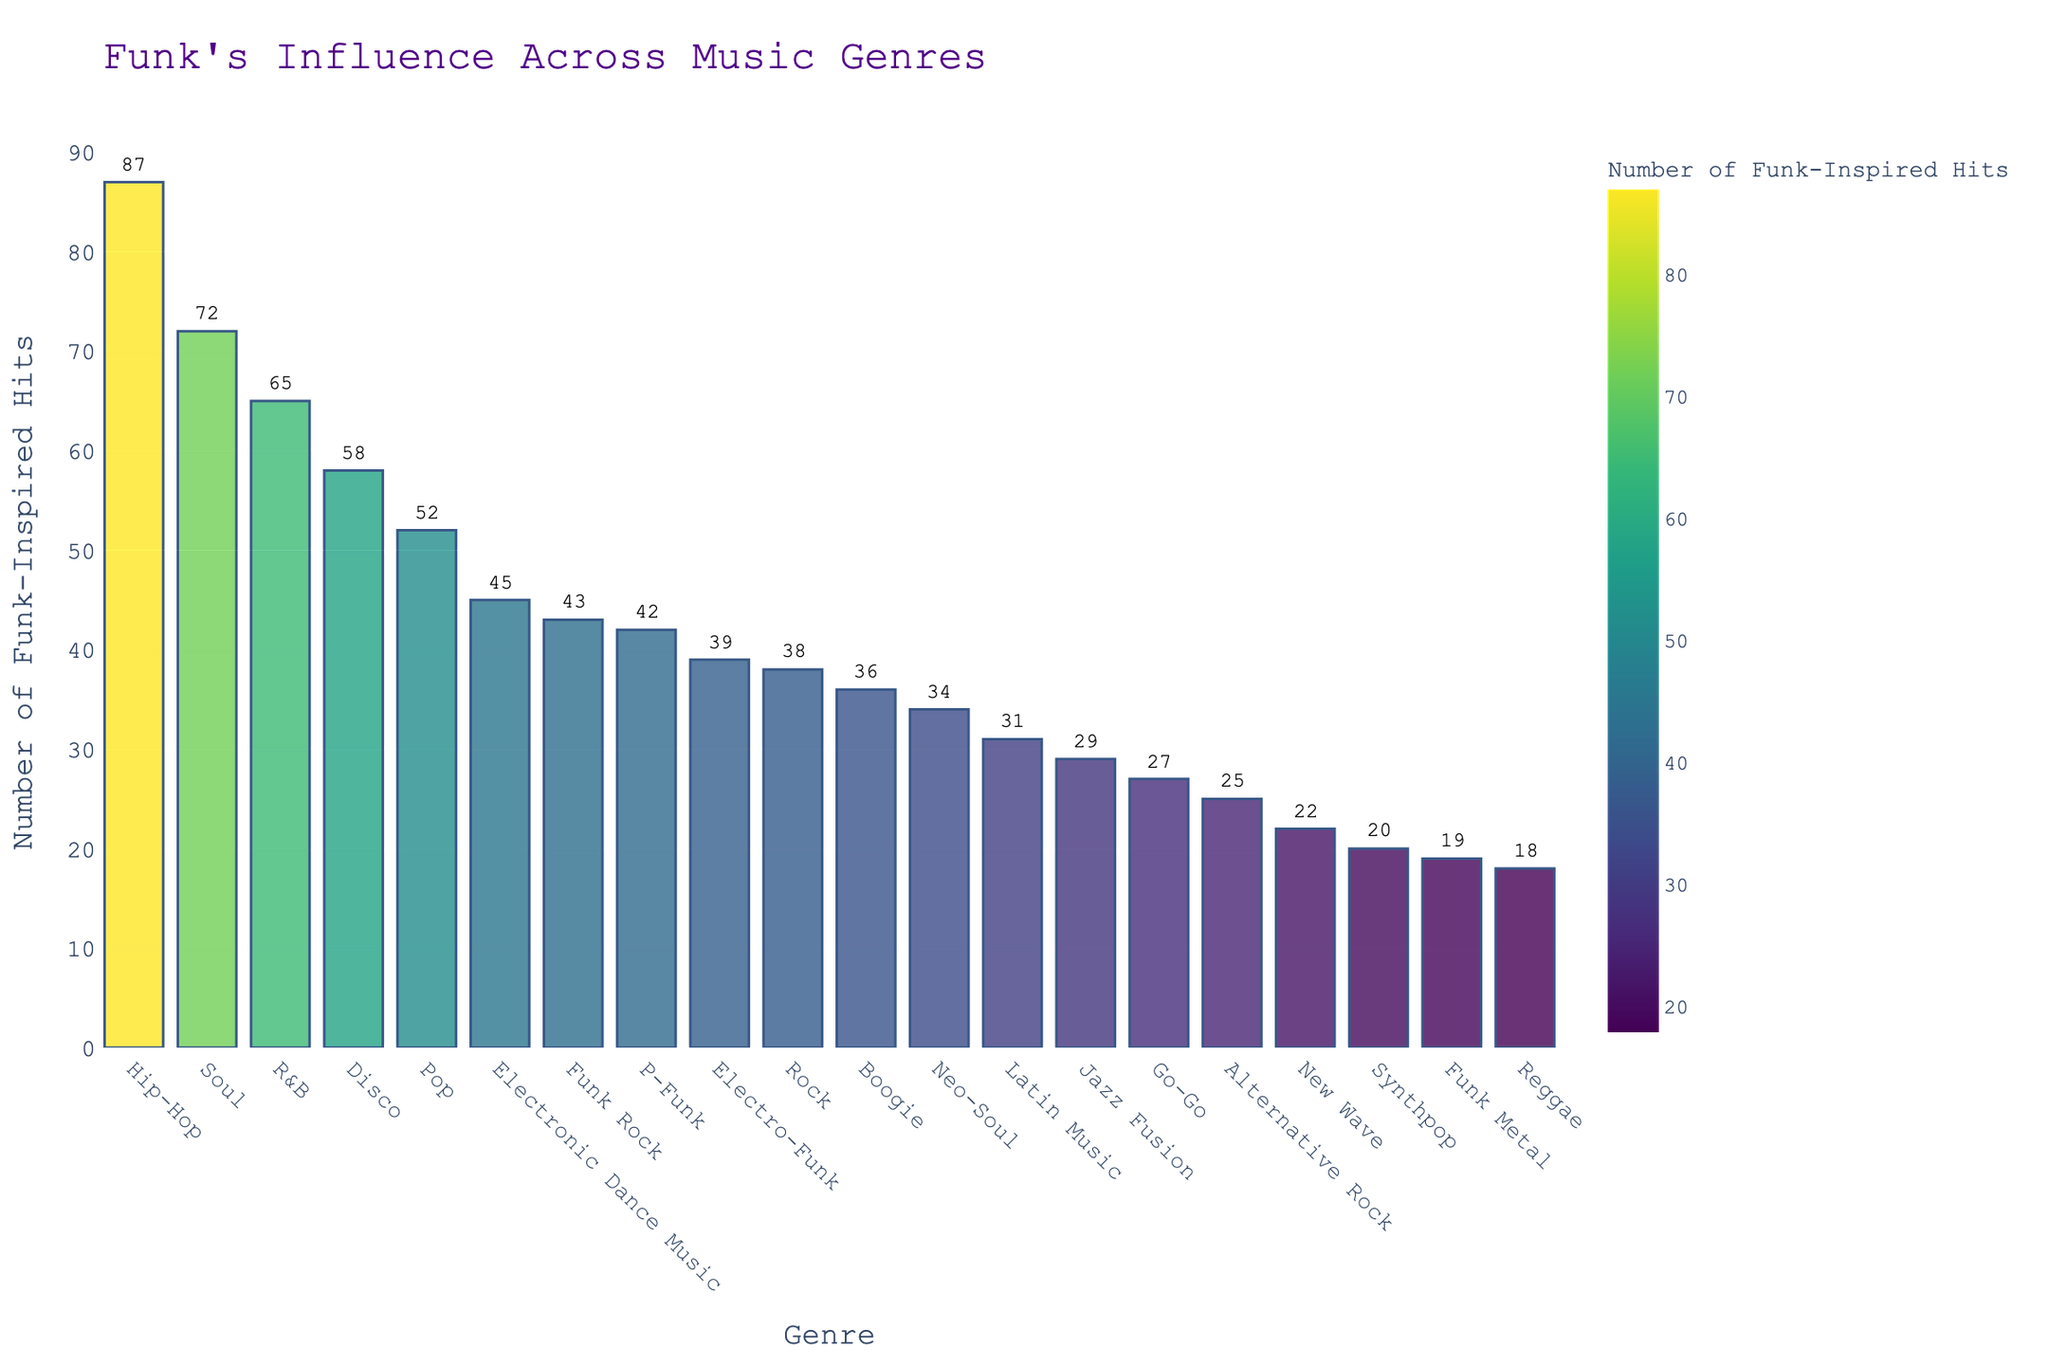What genre has the highest number of funk-inspired hits? By observing the bar chart, the tallest bar corresponds to Hip-Hop, indicating that it has the highest number of funk-inspired hits.
Answer: Hip-Hop Which genre has fewer funk-inspired hits: Jazz Fusion or Disco? By comparing the heights of the bars for Jazz Fusion and Disco, Jazz Fusion has a shorter bar, meaning it has fewer hits.
Answer: Jazz Fusion What is the total number of funk-inspired hits in Pop, Rock, and Electro-Funk combined? Sum the hits from each genre: Pop (52) + Rock (38) + Electro-Funk (39). The total is 52 + 38 + 39 = 129.
Answer: 129 Which genres have more than 50 funk-inspired hits? Identify the genres with bars taller than the level representing 50 hits: Hip-Hop, R&B, Pop, Disco, and Soul.
Answer: Hip-Hop, R&B, Pop, Disco, Soul How much higher is the number of funk-inspired hits in R&B compared to Reggae? Find the difference between the hits in R&B (65) and Reggae (18): 65 - 18 = 47.
Answer: 47 What is the average number of funk-inspired hits across Synthpop, Boogie, and Latin Music? Sum the hits for each genre and divide by the number of genres: (Synthpop: 20, Boogie: 36, Latin Music: 31). The total sum is 20 + 36 + 31 = 87. The average is 87 / 3 ≈ 29.
Answer: 29 Which music style has the closest number of funk-inspired hits to Funk Rock? Look for genres with hit numbers closest to Funk Rock’s 43 hits: P-Funk has 42 hits.
Answer: P-Funk Rank the top three genres with the most funk-inspired hits. Identify the genres with the top three highest bars: 1) Hip-Hop (87), 2) Soul (72), 3) R&B (65).
Answer: 1) Hip-Hop, 2) Soul, 3) R&B How many genres have fewer than 30 funk-inspired hits? Count the genres with bars shorter than the level representing 30 hits: Jazz Fusion, New Wave, Reggae, Alternative Rock, Synthpop, Go-Go, Funk Metal. There are 7 genres.
Answer: 7 What is the difference in funk-inspired hits between the genre with the highest hits and the genre with the lowest hits? Subtract the hits in the genre with the lowest hits (Funk Metal: 19) from the highest (Hip-Hop: 87): 87 - 19 = 68.
Answer: 68 